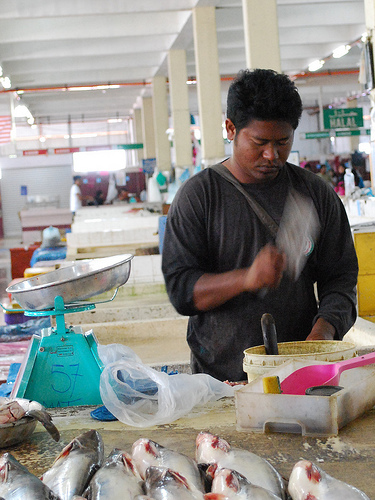<image>
Is there a scoop in the bucket? No. The scoop is not contained within the bucket. These objects have a different spatial relationship. Is there a scale in the fish? No. The scale is not contained within the fish. These objects have a different spatial relationship. 